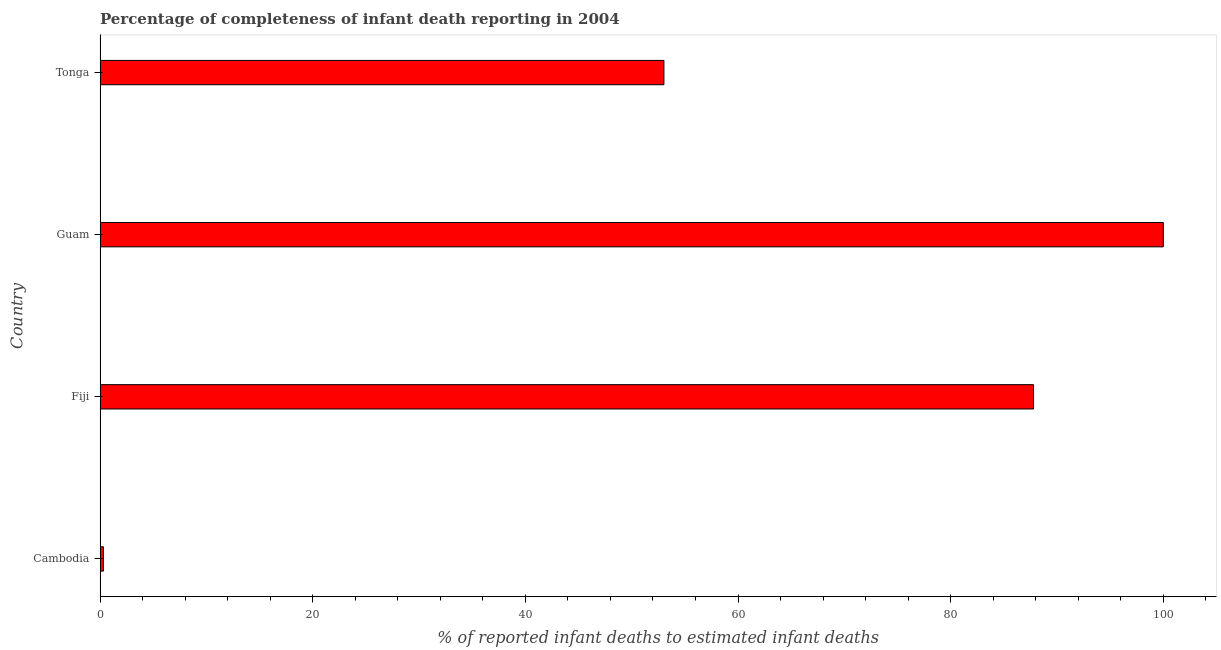What is the title of the graph?
Provide a short and direct response. Percentage of completeness of infant death reporting in 2004. What is the label or title of the X-axis?
Give a very brief answer. % of reported infant deaths to estimated infant deaths. What is the label or title of the Y-axis?
Your response must be concise. Country. What is the completeness of infant death reporting in Tonga?
Give a very brief answer. 53.03. Across all countries, what is the maximum completeness of infant death reporting?
Provide a succinct answer. 100. Across all countries, what is the minimum completeness of infant death reporting?
Your answer should be very brief. 0.32. In which country was the completeness of infant death reporting maximum?
Your response must be concise. Guam. In which country was the completeness of infant death reporting minimum?
Give a very brief answer. Cambodia. What is the sum of the completeness of infant death reporting?
Provide a short and direct response. 241.14. What is the difference between the completeness of infant death reporting in Fiji and Tonga?
Your answer should be compact. 34.76. What is the average completeness of infant death reporting per country?
Ensure brevity in your answer.  60.28. What is the median completeness of infant death reporting?
Your answer should be very brief. 70.41. What is the ratio of the completeness of infant death reporting in Cambodia to that in Tonga?
Your answer should be very brief. 0.01. Is the difference between the completeness of infant death reporting in Cambodia and Fiji greater than the difference between any two countries?
Make the answer very short. No. What is the difference between the highest and the second highest completeness of infant death reporting?
Offer a very short reply. 12.21. Is the sum of the completeness of infant death reporting in Cambodia and Tonga greater than the maximum completeness of infant death reporting across all countries?
Offer a very short reply. No. What is the difference between the highest and the lowest completeness of infant death reporting?
Offer a very short reply. 99.68. In how many countries, is the completeness of infant death reporting greater than the average completeness of infant death reporting taken over all countries?
Offer a terse response. 2. How many bars are there?
Your response must be concise. 4. Are all the bars in the graph horizontal?
Keep it short and to the point. Yes. How many countries are there in the graph?
Your answer should be very brief. 4. What is the difference between two consecutive major ticks on the X-axis?
Your answer should be compact. 20. What is the % of reported infant deaths to estimated infant deaths of Cambodia?
Ensure brevity in your answer.  0.32. What is the % of reported infant deaths to estimated infant deaths in Fiji?
Your answer should be compact. 87.79. What is the % of reported infant deaths to estimated infant deaths of Guam?
Offer a terse response. 100. What is the % of reported infant deaths to estimated infant deaths of Tonga?
Give a very brief answer. 53.03. What is the difference between the % of reported infant deaths to estimated infant deaths in Cambodia and Fiji?
Make the answer very short. -87.47. What is the difference between the % of reported infant deaths to estimated infant deaths in Cambodia and Guam?
Ensure brevity in your answer.  -99.68. What is the difference between the % of reported infant deaths to estimated infant deaths in Cambodia and Tonga?
Make the answer very short. -52.71. What is the difference between the % of reported infant deaths to estimated infant deaths in Fiji and Guam?
Your response must be concise. -12.21. What is the difference between the % of reported infant deaths to estimated infant deaths in Fiji and Tonga?
Make the answer very short. 34.76. What is the difference between the % of reported infant deaths to estimated infant deaths in Guam and Tonga?
Give a very brief answer. 46.97. What is the ratio of the % of reported infant deaths to estimated infant deaths in Cambodia to that in Fiji?
Offer a terse response. 0. What is the ratio of the % of reported infant deaths to estimated infant deaths in Cambodia to that in Guam?
Your answer should be very brief. 0. What is the ratio of the % of reported infant deaths to estimated infant deaths in Cambodia to that in Tonga?
Your response must be concise. 0.01. What is the ratio of the % of reported infant deaths to estimated infant deaths in Fiji to that in Guam?
Make the answer very short. 0.88. What is the ratio of the % of reported infant deaths to estimated infant deaths in Fiji to that in Tonga?
Offer a terse response. 1.66. What is the ratio of the % of reported infant deaths to estimated infant deaths in Guam to that in Tonga?
Provide a succinct answer. 1.89. 